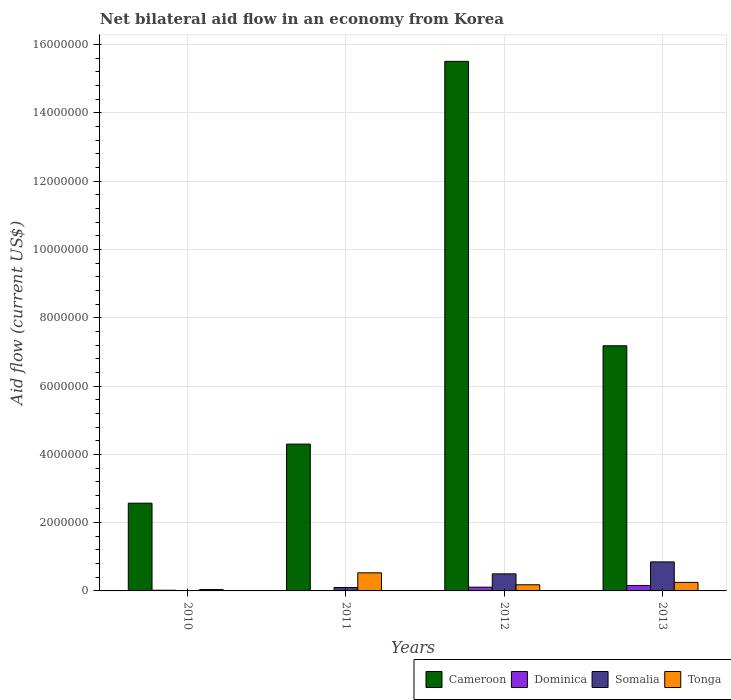How many different coloured bars are there?
Ensure brevity in your answer.  4. Are the number of bars per tick equal to the number of legend labels?
Offer a terse response. Yes. Are the number of bars on each tick of the X-axis equal?
Your response must be concise. Yes. How many bars are there on the 1st tick from the left?
Your answer should be compact. 4. How many bars are there on the 1st tick from the right?
Ensure brevity in your answer.  4. What is the net bilateral aid flow in Cameroon in 2012?
Keep it short and to the point. 1.55e+07. What is the total net bilateral aid flow in Dominica in the graph?
Your response must be concise. 3.00e+05. What is the difference between the net bilateral aid flow in Tonga in 2010 and the net bilateral aid flow in Dominica in 2012?
Your response must be concise. -7.00e+04. What is the average net bilateral aid flow in Dominica per year?
Provide a succinct answer. 7.50e+04. In the year 2012, what is the difference between the net bilateral aid flow in Dominica and net bilateral aid flow in Cameroon?
Ensure brevity in your answer.  -1.54e+07. In how many years, is the net bilateral aid flow in Cameroon greater than 4800000 US$?
Your answer should be very brief. 2. What is the difference between the highest and the second highest net bilateral aid flow in Tonga?
Provide a short and direct response. 2.80e+05. What is the difference between the highest and the lowest net bilateral aid flow in Cameroon?
Provide a short and direct response. 1.29e+07. In how many years, is the net bilateral aid flow in Tonga greater than the average net bilateral aid flow in Tonga taken over all years?
Provide a succinct answer. 1. Is the sum of the net bilateral aid flow in Dominica in 2012 and 2013 greater than the maximum net bilateral aid flow in Tonga across all years?
Your response must be concise. No. What does the 3rd bar from the left in 2011 represents?
Your answer should be compact. Somalia. What does the 4th bar from the right in 2010 represents?
Your response must be concise. Cameroon. Is it the case that in every year, the sum of the net bilateral aid flow in Somalia and net bilateral aid flow in Cameroon is greater than the net bilateral aid flow in Tonga?
Offer a terse response. Yes. How many bars are there?
Offer a terse response. 16. Are all the bars in the graph horizontal?
Offer a very short reply. No. Does the graph contain grids?
Provide a short and direct response. Yes. How many legend labels are there?
Keep it short and to the point. 4. How are the legend labels stacked?
Keep it short and to the point. Horizontal. What is the title of the graph?
Offer a terse response. Net bilateral aid flow in an economy from Korea. What is the label or title of the X-axis?
Make the answer very short. Years. What is the label or title of the Y-axis?
Ensure brevity in your answer.  Aid flow (current US$). What is the Aid flow (current US$) in Cameroon in 2010?
Make the answer very short. 2.57e+06. What is the Aid flow (current US$) in Dominica in 2010?
Ensure brevity in your answer.  2.00e+04. What is the Aid flow (current US$) in Cameroon in 2011?
Your answer should be compact. 4.30e+06. What is the Aid flow (current US$) of Dominica in 2011?
Your answer should be very brief. 10000. What is the Aid flow (current US$) in Somalia in 2011?
Your response must be concise. 1.00e+05. What is the Aid flow (current US$) in Tonga in 2011?
Your response must be concise. 5.30e+05. What is the Aid flow (current US$) of Cameroon in 2012?
Keep it short and to the point. 1.55e+07. What is the Aid flow (current US$) in Dominica in 2012?
Provide a succinct answer. 1.10e+05. What is the Aid flow (current US$) of Somalia in 2012?
Your answer should be compact. 5.00e+05. What is the Aid flow (current US$) in Tonga in 2012?
Give a very brief answer. 1.80e+05. What is the Aid flow (current US$) in Cameroon in 2013?
Make the answer very short. 7.18e+06. What is the Aid flow (current US$) of Dominica in 2013?
Provide a short and direct response. 1.60e+05. What is the Aid flow (current US$) of Somalia in 2013?
Give a very brief answer. 8.50e+05. Across all years, what is the maximum Aid flow (current US$) of Cameroon?
Make the answer very short. 1.55e+07. Across all years, what is the maximum Aid flow (current US$) of Somalia?
Offer a terse response. 8.50e+05. Across all years, what is the maximum Aid flow (current US$) in Tonga?
Your answer should be very brief. 5.30e+05. Across all years, what is the minimum Aid flow (current US$) of Cameroon?
Provide a short and direct response. 2.57e+06. Across all years, what is the minimum Aid flow (current US$) of Somalia?
Keep it short and to the point. 10000. Across all years, what is the minimum Aid flow (current US$) in Tonga?
Make the answer very short. 4.00e+04. What is the total Aid flow (current US$) of Cameroon in the graph?
Your response must be concise. 2.96e+07. What is the total Aid flow (current US$) in Dominica in the graph?
Make the answer very short. 3.00e+05. What is the total Aid flow (current US$) in Somalia in the graph?
Offer a terse response. 1.46e+06. What is the difference between the Aid flow (current US$) of Cameroon in 2010 and that in 2011?
Give a very brief answer. -1.73e+06. What is the difference between the Aid flow (current US$) of Somalia in 2010 and that in 2011?
Ensure brevity in your answer.  -9.00e+04. What is the difference between the Aid flow (current US$) in Tonga in 2010 and that in 2011?
Offer a terse response. -4.90e+05. What is the difference between the Aid flow (current US$) of Cameroon in 2010 and that in 2012?
Your response must be concise. -1.29e+07. What is the difference between the Aid flow (current US$) in Somalia in 2010 and that in 2012?
Offer a terse response. -4.90e+05. What is the difference between the Aid flow (current US$) of Cameroon in 2010 and that in 2013?
Make the answer very short. -4.61e+06. What is the difference between the Aid flow (current US$) in Dominica in 2010 and that in 2013?
Your answer should be compact. -1.40e+05. What is the difference between the Aid flow (current US$) in Somalia in 2010 and that in 2013?
Make the answer very short. -8.40e+05. What is the difference between the Aid flow (current US$) of Cameroon in 2011 and that in 2012?
Your response must be concise. -1.12e+07. What is the difference between the Aid flow (current US$) in Somalia in 2011 and that in 2012?
Offer a very short reply. -4.00e+05. What is the difference between the Aid flow (current US$) in Tonga in 2011 and that in 2012?
Ensure brevity in your answer.  3.50e+05. What is the difference between the Aid flow (current US$) in Cameroon in 2011 and that in 2013?
Ensure brevity in your answer.  -2.88e+06. What is the difference between the Aid flow (current US$) in Dominica in 2011 and that in 2013?
Your answer should be very brief. -1.50e+05. What is the difference between the Aid flow (current US$) in Somalia in 2011 and that in 2013?
Make the answer very short. -7.50e+05. What is the difference between the Aid flow (current US$) in Cameroon in 2012 and that in 2013?
Make the answer very short. 8.33e+06. What is the difference between the Aid flow (current US$) in Somalia in 2012 and that in 2013?
Your answer should be compact. -3.50e+05. What is the difference between the Aid flow (current US$) of Tonga in 2012 and that in 2013?
Provide a succinct answer. -7.00e+04. What is the difference between the Aid flow (current US$) in Cameroon in 2010 and the Aid flow (current US$) in Dominica in 2011?
Give a very brief answer. 2.56e+06. What is the difference between the Aid flow (current US$) of Cameroon in 2010 and the Aid flow (current US$) of Somalia in 2011?
Your answer should be very brief. 2.47e+06. What is the difference between the Aid flow (current US$) of Cameroon in 2010 and the Aid flow (current US$) of Tonga in 2011?
Ensure brevity in your answer.  2.04e+06. What is the difference between the Aid flow (current US$) of Dominica in 2010 and the Aid flow (current US$) of Somalia in 2011?
Give a very brief answer. -8.00e+04. What is the difference between the Aid flow (current US$) in Dominica in 2010 and the Aid flow (current US$) in Tonga in 2011?
Your response must be concise. -5.10e+05. What is the difference between the Aid flow (current US$) in Somalia in 2010 and the Aid flow (current US$) in Tonga in 2011?
Your response must be concise. -5.20e+05. What is the difference between the Aid flow (current US$) of Cameroon in 2010 and the Aid flow (current US$) of Dominica in 2012?
Your answer should be very brief. 2.46e+06. What is the difference between the Aid flow (current US$) of Cameroon in 2010 and the Aid flow (current US$) of Somalia in 2012?
Offer a very short reply. 2.07e+06. What is the difference between the Aid flow (current US$) of Cameroon in 2010 and the Aid flow (current US$) of Tonga in 2012?
Make the answer very short. 2.39e+06. What is the difference between the Aid flow (current US$) of Dominica in 2010 and the Aid flow (current US$) of Somalia in 2012?
Keep it short and to the point. -4.80e+05. What is the difference between the Aid flow (current US$) of Dominica in 2010 and the Aid flow (current US$) of Tonga in 2012?
Keep it short and to the point. -1.60e+05. What is the difference between the Aid flow (current US$) in Cameroon in 2010 and the Aid flow (current US$) in Dominica in 2013?
Your answer should be very brief. 2.41e+06. What is the difference between the Aid flow (current US$) in Cameroon in 2010 and the Aid flow (current US$) in Somalia in 2013?
Make the answer very short. 1.72e+06. What is the difference between the Aid flow (current US$) of Cameroon in 2010 and the Aid flow (current US$) of Tonga in 2013?
Offer a very short reply. 2.32e+06. What is the difference between the Aid flow (current US$) in Dominica in 2010 and the Aid flow (current US$) in Somalia in 2013?
Your answer should be compact. -8.30e+05. What is the difference between the Aid flow (current US$) of Somalia in 2010 and the Aid flow (current US$) of Tonga in 2013?
Offer a very short reply. -2.40e+05. What is the difference between the Aid flow (current US$) in Cameroon in 2011 and the Aid flow (current US$) in Dominica in 2012?
Your answer should be very brief. 4.19e+06. What is the difference between the Aid flow (current US$) in Cameroon in 2011 and the Aid flow (current US$) in Somalia in 2012?
Keep it short and to the point. 3.80e+06. What is the difference between the Aid flow (current US$) in Cameroon in 2011 and the Aid flow (current US$) in Tonga in 2012?
Make the answer very short. 4.12e+06. What is the difference between the Aid flow (current US$) in Dominica in 2011 and the Aid flow (current US$) in Somalia in 2012?
Your response must be concise. -4.90e+05. What is the difference between the Aid flow (current US$) of Dominica in 2011 and the Aid flow (current US$) of Tonga in 2012?
Keep it short and to the point. -1.70e+05. What is the difference between the Aid flow (current US$) of Cameroon in 2011 and the Aid flow (current US$) of Dominica in 2013?
Provide a succinct answer. 4.14e+06. What is the difference between the Aid flow (current US$) of Cameroon in 2011 and the Aid flow (current US$) of Somalia in 2013?
Give a very brief answer. 3.45e+06. What is the difference between the Aid flow (current US$) in Cameroon in 2011 and the Aid flow (current US$) in Tonga in 2013?
Offer a very short reply. 4.05e+06. What is the difference between the Aid flow (current US$) of Dominica in 2011 and the Aid flow (current US$) of Somalia in 2013?
Ensure brevity in your answer.  -8.40e+05. What is the difference between the Aid flow (current US$) of Somalia in 2011 and the Aid flow (current US$) of Tonga in 2013?
Make the answer very short. -1.50e+05. What is the difference between the Aid flow (current US$) in Cameroon in 2012 and the Aid flow (current US$) in Dominica in 2013?
Your response must be concise. 1.54e+07. What is the difference between the Aid flow (current US$) of Cameroon in 2012 and the Aid flow (current US$) of Somalia in 2013?
Make the answer very short. 1.47e+07. What is the difference between the Aid flow (current US$) in Cameroon in 2012 and the Aid flow (current US$) in Tonga in 2013?
Keep it short and to the point. 1.53e+07. What is the difference between the Aid flow (current US$) in Dominica in 2012 and the Aid flow (current US$) in Somalia in 2013?
Provide a succinct answer. -7.40e+05. What is the difference between the Aid flow (current US$) of Somalia in 2012 and the Aid flow (current US$) of Tonga in 2013?
Your response must be concise. 2.50e+05. What is the average Aid flow (current US$) of Cameroon per year?
Your answer should be very brief. 7.39e+06. What is the average Aid flow (current US$) in Dominica per year?
Provide a short and direct response. 7.50e+04. What is the average Aid flow (current US$) of Somalia per year?
Make the answer very short. 3.65e+05. What is the average Aid flow (current US$) of Tonga per year?
Your answer should be compact. 2.50e+05. In the year 2010, what is the difference between the Aid flow (current US$) of Cameroon and Aid flow (current US$) of Dominica?
Give a very brief answer. 2.55e+06. In the year 2010, what is the difference between the Aid flow (current US$) of Cameroon and Aid flow (current US$) of Somalia?
Offer a terse response. 2.56e+06. In the year 2010, what is the difference between the Aid flow (current US$) in Cameroon and Aid flow (current US$) in Tonga?
Offer a terse response. 2.53e+06. In the year 2010, what is the difference between the Aid flow (current US$) of Somalia and Aid flow (current US$) of Tonga?
Provide a succinct answer. -3.00e+04. In the year 2011, what is the difference between the Aid flow (current US$) of Cameroon and Aid flow (current US$) of Dominica?
Ensure brevity in your answer.  4.29e+06. In the year 2011, what is the difference between the Aid flow (current US$) of Cameroon and Aid flow (current US$) of Somalia?
Offer a very short reply. 4.20e+06. In the year 2011, what is the difference between the Aid flow (current US$) of Cameroon and Aid flow (current US$) of Tonga?
Your answer should be compact. 3.77e+06. In the year 2011, what is the difference between the Aid flow (current US$) of Dominica and Aid flow (current US$) of Tonga?
Ensure brevity in your answer.  -5.20e+05. In the year 2011, what is the difference between the Aid flow (current US$) in Somalia and Aid flow (current US$) in Tonga?
Provide a short and direct response. -4.30e+05. In the year 2012, what is the difference between the Aid flow (current US$) of Cameroon and Aid flow (current US$) of Dominica?
Provide a short and direct response. 1.54e+07. In the year 2012, what is the difference between the Aid flow (current US$) of Cameroon and Aid flow (current US$) of Somalia?
Your response must be concise. 1.50e+07. In the year 2012, what is the difference between the Aid flow (current US$) of Cameroon and Aid flow (current US$) of Tonga?
Offer a very short reply. 1.53e+07. In the year 2012, what is the difference between the Aid flow (current US$) of Dominica and Aid flow (current US$) of Somalia?
Your answer should be compact. -3.90e+05. In the year 2012, what is the difference between the Aid flow (current US$) in Somalia and Aid flow (current US$) in Tonga?
Your response must be concise. 3.20e+05. In the year 2013, what is the difference between the Aid flow (current US$) of Cameroon and Aid flow (current US$) of Dominica?
Your answer should be compact. 7.02e+06. In the year 2013, what is the difference between the Aid flow (current US$) of Cameroon and Aid flow (current US$) of Somalia?
Your answer should be compact. 6.33e+06. In the year 2013, what is the difference between the Aid flow (current US$) of Cameroon and Aid flow (current US$) of Tonga?
Your response must be concise. 6.93e+06. In the year 2013, what is the difference between the Aid flow (current US$) of Dominica and Aid flow (current US$) of Somalia?
Make the answer very short. -6.90e+05. What is the ratio of the Aid flow (current US$) of Cameroon in 2010 to that in 2011?
Make the answer very short. 0.6. What is the ratio of the Aid flow (current US$) of Dominica in 2010 to that in 2011?
Offer a very short reply. 2. What is the ratio of the Aid flow (current US$) of Somalia in 2010 to that in 2011?
Provide a succinct answer. 0.1. What is the ratio of the Aid flow (current US$) in Tonga in 2010 to that in 2011?
Your answer should be very brief. 0.08. What is the ratio of the Aid flow (current US$) of Cameroon in 2010 to that in 2012?
Provide a short and direct response. 0.17. What is the ratio of the Aid flow (current US$) of Dominica in 2010 to that in 2012?
Make the answer very short. 0.18. What is the ratio of the Aid flow (current US$) of Tonga in 2010 to that in 2012?
Offer a very short reply. 0.22. What is the ratio of the Aid flow (current US$) in Cameroon in 2010 to that in 2013?
Offer a terse response. 0.36. What is the ratio of the Aid flow (current US$) in Dominica in 2010 to that in 2013?
Ensure brevity in your answer.  0.12. What is the ratio of the Aid flow (current US$) in Somalia in 2010 to that in 2013?
Offer a terse response. 0.01. What is the ratio of the Aid flow (current US$) in Tonga in 2010 to that in 2013?
Provide a short and direct response. 0.16. What is the ratio of the Aid flow (current US$) in Cameroon in 2011 to that in 2012?
Provide a short and direct response. 0.28. What is the ratio of the Aid flow (current US$) in Dominica in 2011 to that in 2012?
Ensure brevity in your answer.  0.09. What is the ratio of the Aid flow (current US$) in Tonga in 2011 to that in 2012?
Your answer should be compact. 2.94. What is the ratio of the Aid flow (current US$) in Cameroon in 2011 to that in 2013?
Keep it short and to the point. 0.6. What is the ratio of the Aid flow (current US$) in Dominica in 2011 to that in 2013?
Your answer should be very brief. 0.06. What is the ratio of the Aid flow (current US$) in Somalia in 2011 to that in 2013?
Ensure brevity in your answer.  0.12. What is the ratio of the Aid flow (current US$) of Tonga in 2011 to that in 2013?
Provide a short and direct response. 2.12. What is the ratio of the Aid flow (current US$) in Cameroon in 2012 to that in 2013?
Offer a terse response. 2.16. What is the ratio of the Aid flow (current US$) in Dominica in 2012 to that in 2013?
Offer a terse response. 0.69. What is the ratio of the Aid flow (current US$) of Somalia in 2012 to that in 2013?
Offer a very short reply. 0.59. What is the ratio of the Aid flow (current US$) in Tonga in 2012 to that in 2013?
Provide a succinct answer. 0.72. What is the difference between the highest and the second highest Aid flow (current US$) in Cameroon?
Make the answer very short. 8.33e+06. What is the difference between the highest and the second highest Aid flow (current US$) in Somalia?
Give a very brief answer. 3.50e+05. What is the difference between the highest and the second highest Aid flow (current US$) in Tonga?
Give a very brief answer. 2.80e+05. What is the difference between the highest and the lowest Aid flow (current US$) in Cameroon?
Provide a succinct answer. 1.29e+07. What is the difference between the highest and the lowest Aid flow (current US$) in Somalia?
Give a very brief answer. 8.40e+05. What is the difference between the highest and the lowest Aid flow (current US$) in Tonga?
Your answer should be very brief. 4.90e+05. 